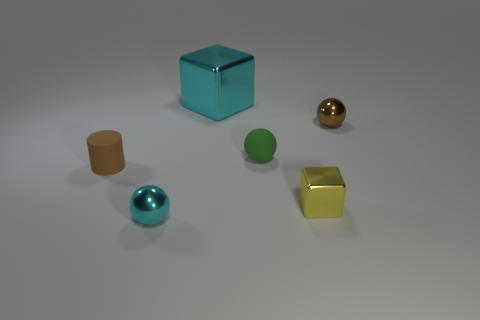Add 3 big cyan metallic blocks. How many objects exist? 9 Subtract all cylinders. How many objects are left? 5 Subtract all cyan things. Subtract all cyan metal blocks. How many objects are left? 3 Add 3 yellow blocks. How many yellow blocks are left? 4 Add 3 tiny gray cubes. How many tiny gray cubes exist? 3 Subtract 0 red cylinders. How many objects are left? 6 